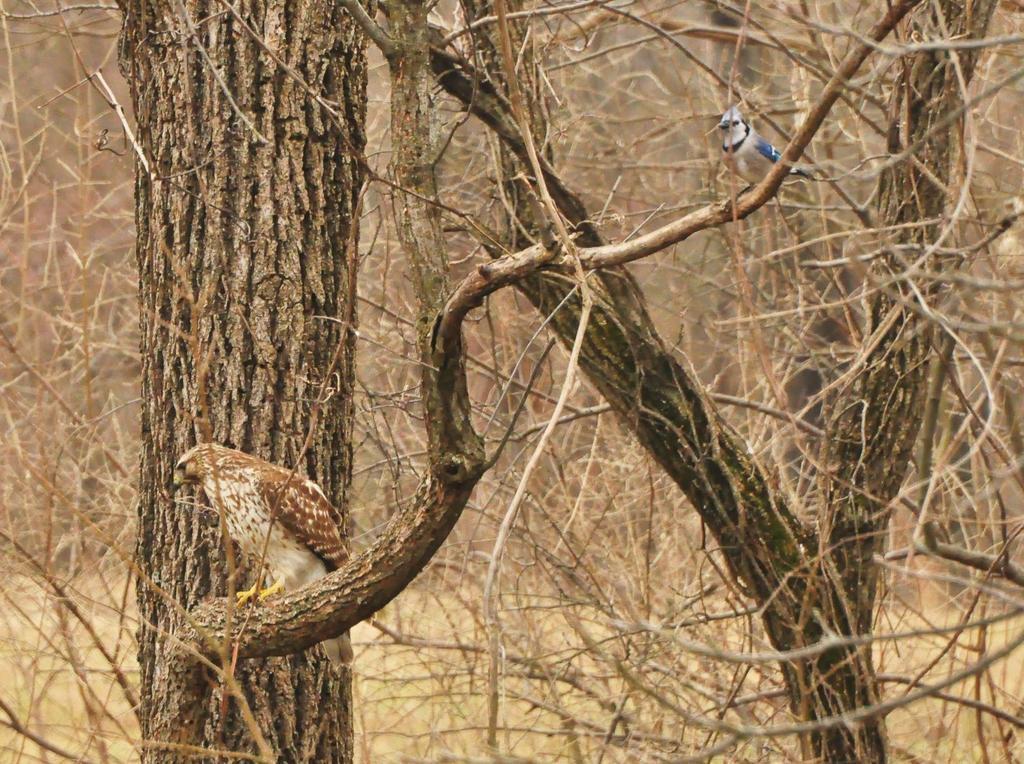Describe this image in one or two sentences. In this image we can see birds on the branch of a tree. In the background we can see bare trees. 